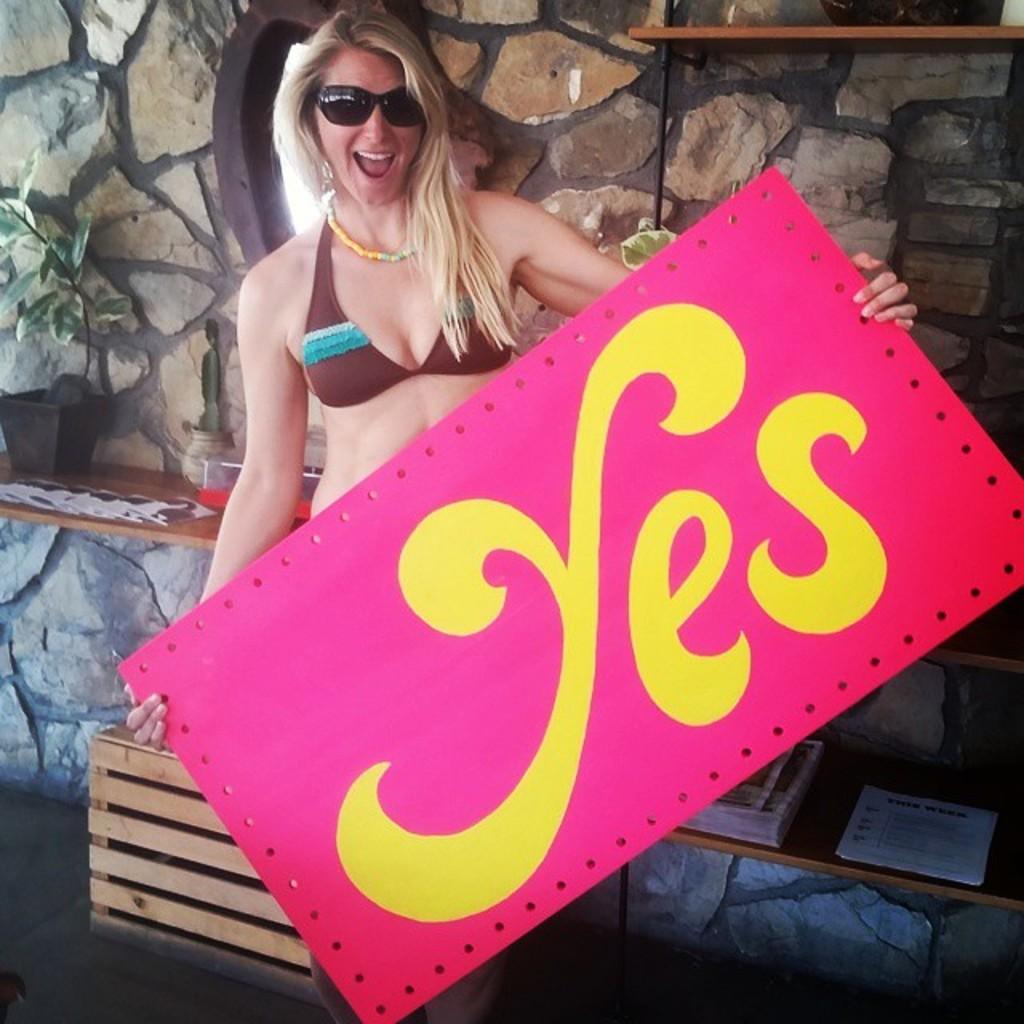In one or two sentences, can you explain what this image depicts? In this image, in the middle, we can see a woman holding a board in her hand. In the background, we can see a stand, on that stand, we can see a flower pot and plant jars. On the right side, we can also see another table, on that table, we can see two books. In the background, we can see a wall. 